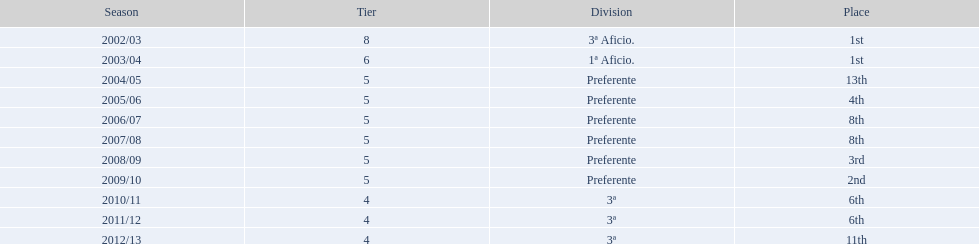Which division has the largest number of ranks? Preferente. 